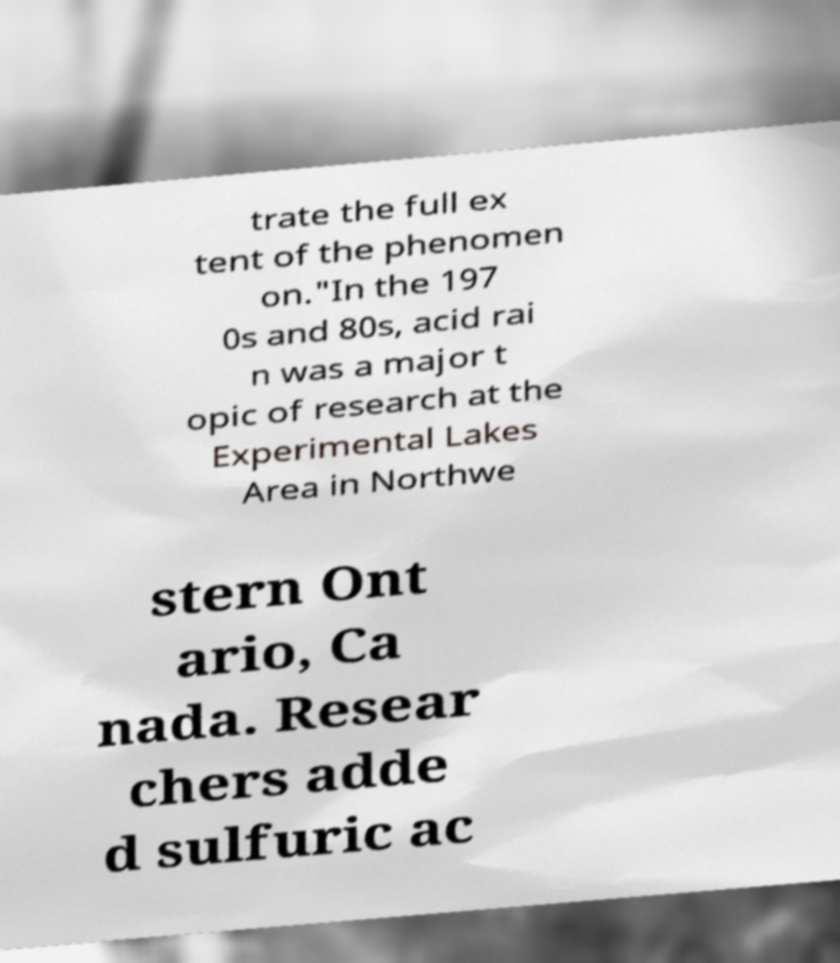There's text embedded in this image that I need extracted. Can you transcribe it verbatim? trate the full ex tent of the phenomen on."In the 197 0s and 80s, acid rai n was a major t opic of research at the Experimental Lakes Area in Northwe stern Ont ario, Ca nada. Resear chers adde d sulfuric ac 